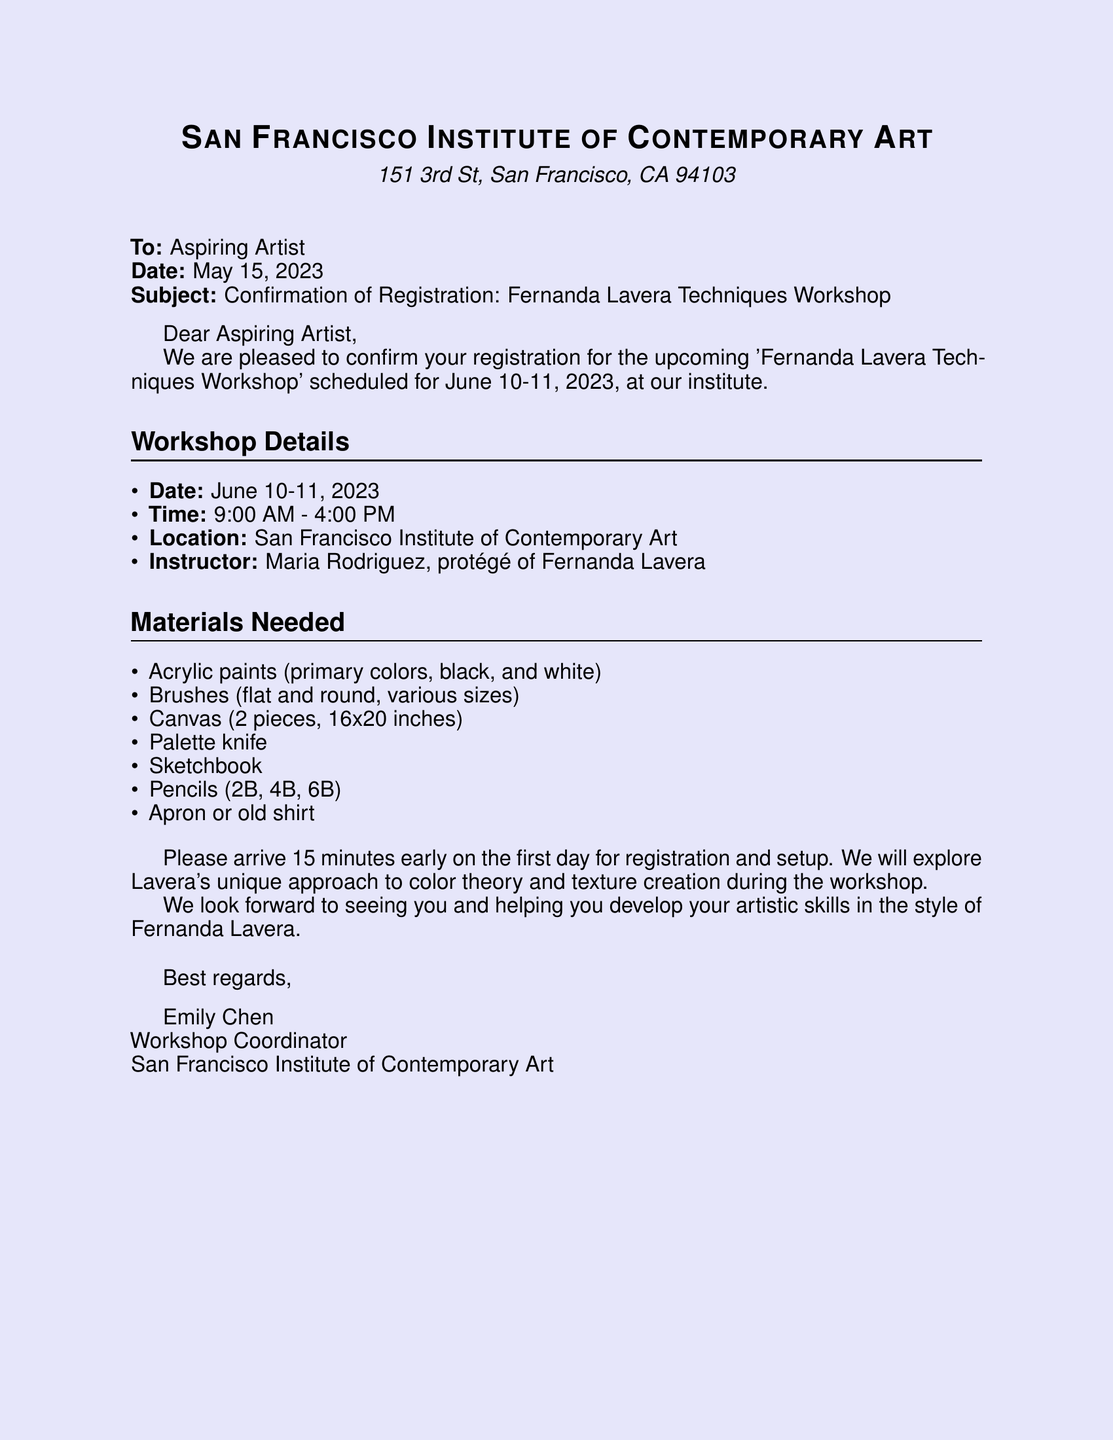What is the title of the workshop? The title of the workshop is mentioned in the subject line of the fax.
Answer: Fernanda Lavera Techniques Workshop Who is the instructor? The instructor's name is provided in the workshop details.
Answer: Maria Rodriguez When is the workshop scheduled? The dates for the workshop are clearly stated in the workshop details section of the document.
Answer: June 10-11, 2023 How many canvas pieces are needed? The document specifies the number of canvas pieces required in the materials list.
Answer: 2 pieces What is the location of the workshop? The location of the workshop is included in the header of the document.
Answer: San Francisco Institute of Contemporary Art What time does the workshop start? The starting time is stated in the workshop details section.
Answer: 9:00 AM What should participants bring for sketching? The materials needed for sketching are mentioned under the materials list.
Answer: Sketchbook Why should participants arrive early? The reason for arriving early is stated within the workshop details section.
Answer: For registration and setup What color paints are required? The required paint colors are listed in the materials needed section.
Answer: Primary colors, black, and white 